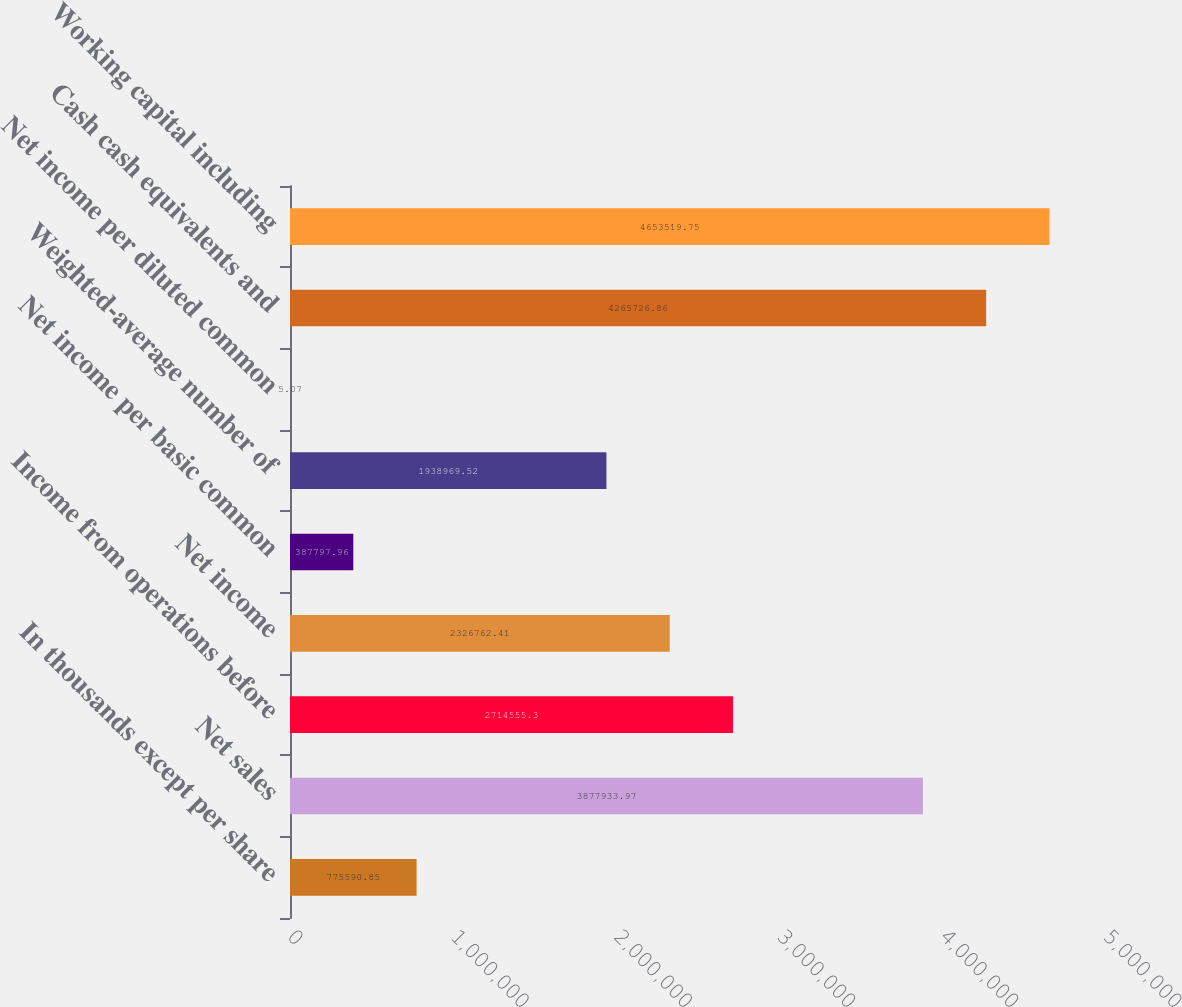Convert chart to OTSL. <chart><loc_0><loc_0><loc_500><loc_500><bar_chart><fcel>In thousands except per share<fcel>Net sales<fcel>Income from operations before<fcel>Net income<fcel>Net income per basic common<fcel>Weighted-average number of<fcel>Net income per diluted common<fcel>Cash cash equivalents and<fcel>Working capital including<nl><fcel>775591<fcel>3.87793e+06<fcel>2.71456e+06<fcel>2.32676e+06<fcel>387798<fcel>1.93897e+06<fcel>5.07<fcel>4.26573e+06<fcel>4.65352e+06<nl></chart> 